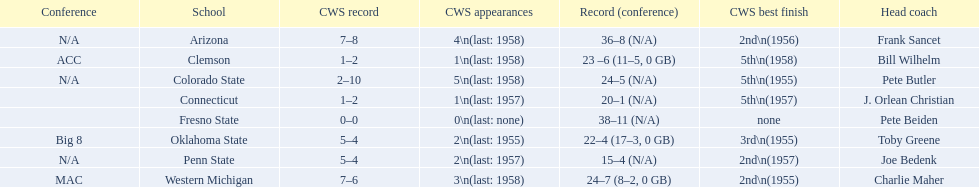Which team did not have more than 16 wins? Penn State. 